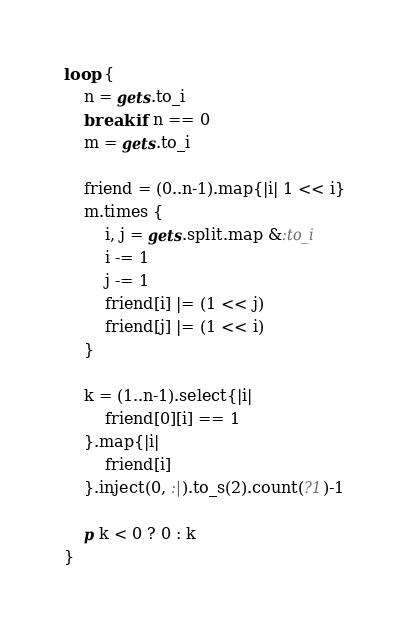<code> <loc_0><loc_0><loc_500><loc_500><_Ruby_>loop {
	n = gets.to_i
	break if n == 0
	m = gets.to_i

	friend = (0..n-1).map{|i| 1 << i}
	m.times {
		i, j = gets.split.map &:to_i
		i -= 1
		j -= 1
		friend[i] |= (1 << j)
		friend[j] |= (1 << i)
	}

	k = (1..n-1).select{|i|
		friend[0][i] == 1
	}.map{|i|
		friend[i]
	}.inject(0, :|).to_s(2).count(?1)-1

	p k < 0 ? 0 : k
}</code> 